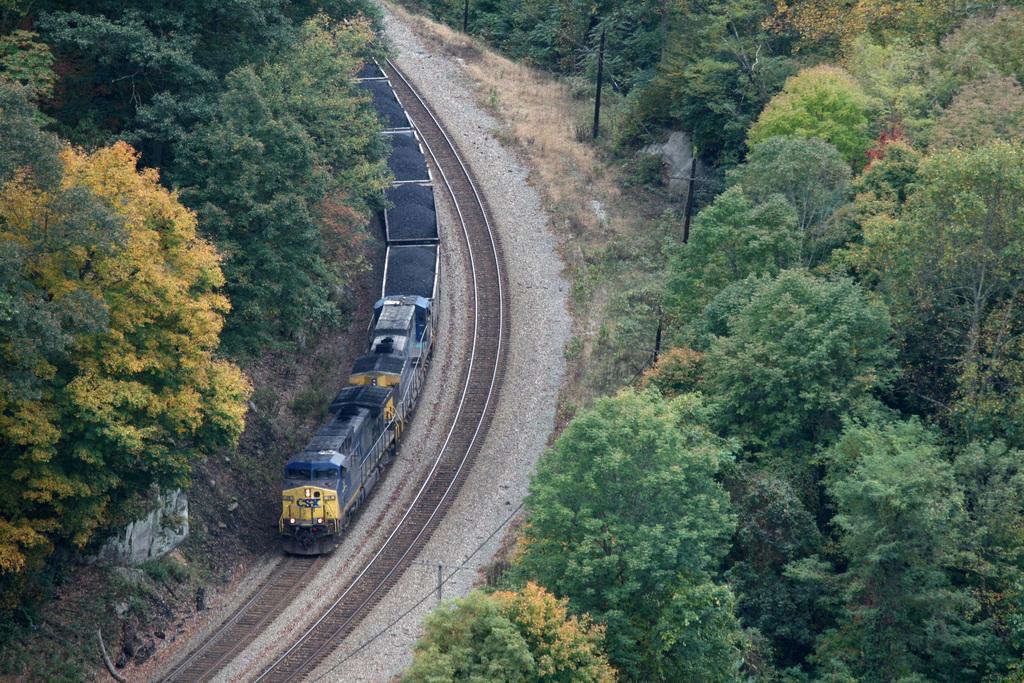How would you summarize this image in a sentence or two? In this picture we can see a train on a railway track. We can see a few trees on the right and left side of the image. There are some poles and plants on the right side. We can see a wire on the poles. 